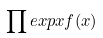Convert formula to latex. <formula><loc_0><loc_0><loc_500><loc_500>\prod e x p x f ( x )</formula> 